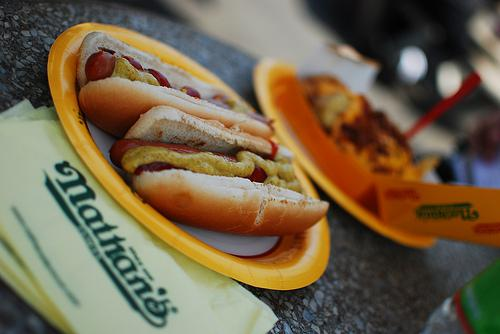Question: what are the hotdogs on?
Choices:
A. A bun.
B. A plate.
C. A paper towel.
D. The grill.
Answer with the letter. Answer: B Question: where is the picture taken?
Choices:
A. Nathan's.
B. Bill's.
C. Michael's.
D. Charlie's.
Answer with the letter. Answer: A Question: how many hot dogs are there?
Choices:
A. Five.
B. Two.
C. Three.
D. Six.
Answer with the letter. Answer: B Question: what is on the hot dogs?
Choices:
A. Ketchup.
B. Onions.
C. Relish.
D. Mustard.
Answer with the letter. Answer: D 